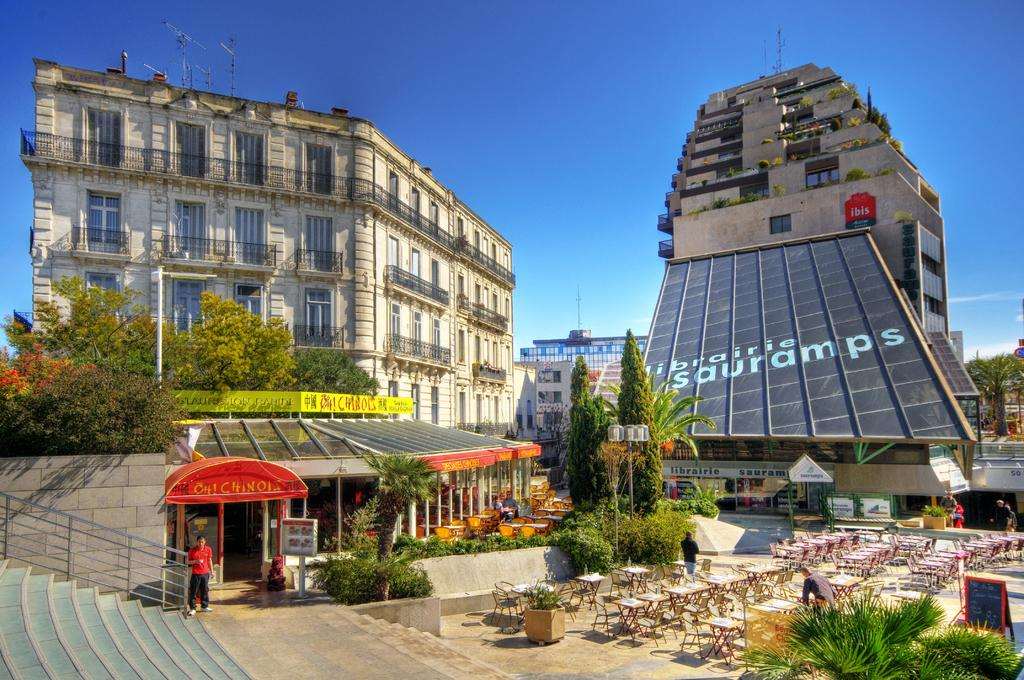What type of structures can be seen in the image? There are buildings in the image. What type of vegetation is present in the image? There are trees in the image. What architectural feature is visible in the image? There are stairs in the image. What type of furniture is present in the image? There are chairs and tables in the image. What type of vertical structures are present in the image? There are poles in the image. What type of signage is present in the image? There are name boards and sign boards in the image. What type of decorative objects are present in the image? There are flower pots in the image. What is visible at the top of the image? The sky is visible at the top of the image. Can you see a mountain in the image? There is no mountain present in the image. How do the buildings join together in the image? The buildings do not join together in the image; they are separate structures. 